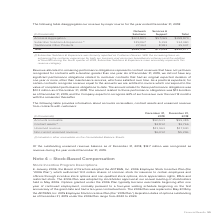According to Adtran's financial document, What does the table show? disaggregates our revenue by major source for the year ended December 31, 2018. The document states: "The following table disaggregates our revenue by major source for the year ended December 31, 2018:..." Also, What was the revenue from Access & Aggregation for Network Solutions? According to the financial document, $301,801 (in thousands). The relevant text states: "Access & Aggregation $301,801 $57,069 $358,870..." Also, What was the total revenue from Network Solutions? According to the financial document, $458,232 (in thousands). The relevant text states: "Total $458,232 $71,045 $529,277..." Also, can you calculate: What was the difference between the total revenue from Network Solutions and Services & Support? Based on the calculation: $458,232-$71,045, the result is 387187 (in thousands). This is based on the information: "Total $458,232 $71,045 $529,277 Total $458,232 $71,045 $529,277..." The key data points involved are: 458,232, 71,045. Also, can you calculate: What was the difference between the total revenue from Subscriber Solutions & Experience and Traditional & Other Products? Based on the calculation: 134,460-35,947, the result is 98513 (in thousands). This is based on the information: "bscriber Solutions & Experience (1) 129,067 5,393 134,460 Traditional & Other Products 27,364 8,583 35,947..." The key data points involved are: 134,460, 35,947. Also, can you calculate: What was the total revenue from traditional & other products as a percentage of total revenue from all sources? Based on the calculation: 35,947/$529,277, the result is 6.79 (percentage). This is based on the information: "Total $458,232 $71,045 $529,277 Traditional & Other Products 27,364 8,583 35,947..." The key data points involved are: 35,947, 529,277. 